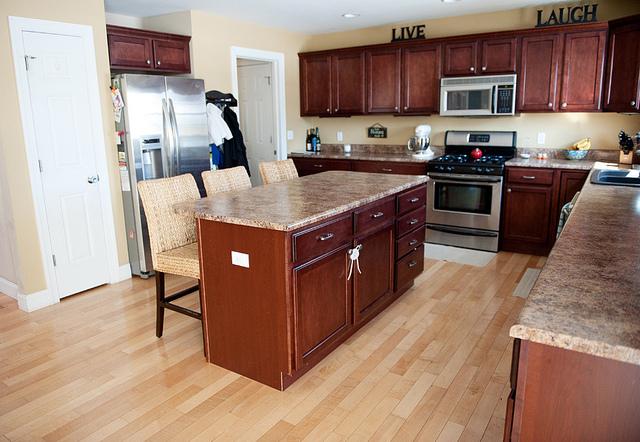What color are the appliances?
Be succinct. Silver. Does this kitchen look expensive?
Quick response, please. Yes. Do people eat meals in the kitchen?
Keep it brief. Yes. Is the table wooden?
Be succinct. No. What third word would you expect to see displayed with these two?
Be succinct. Love. 